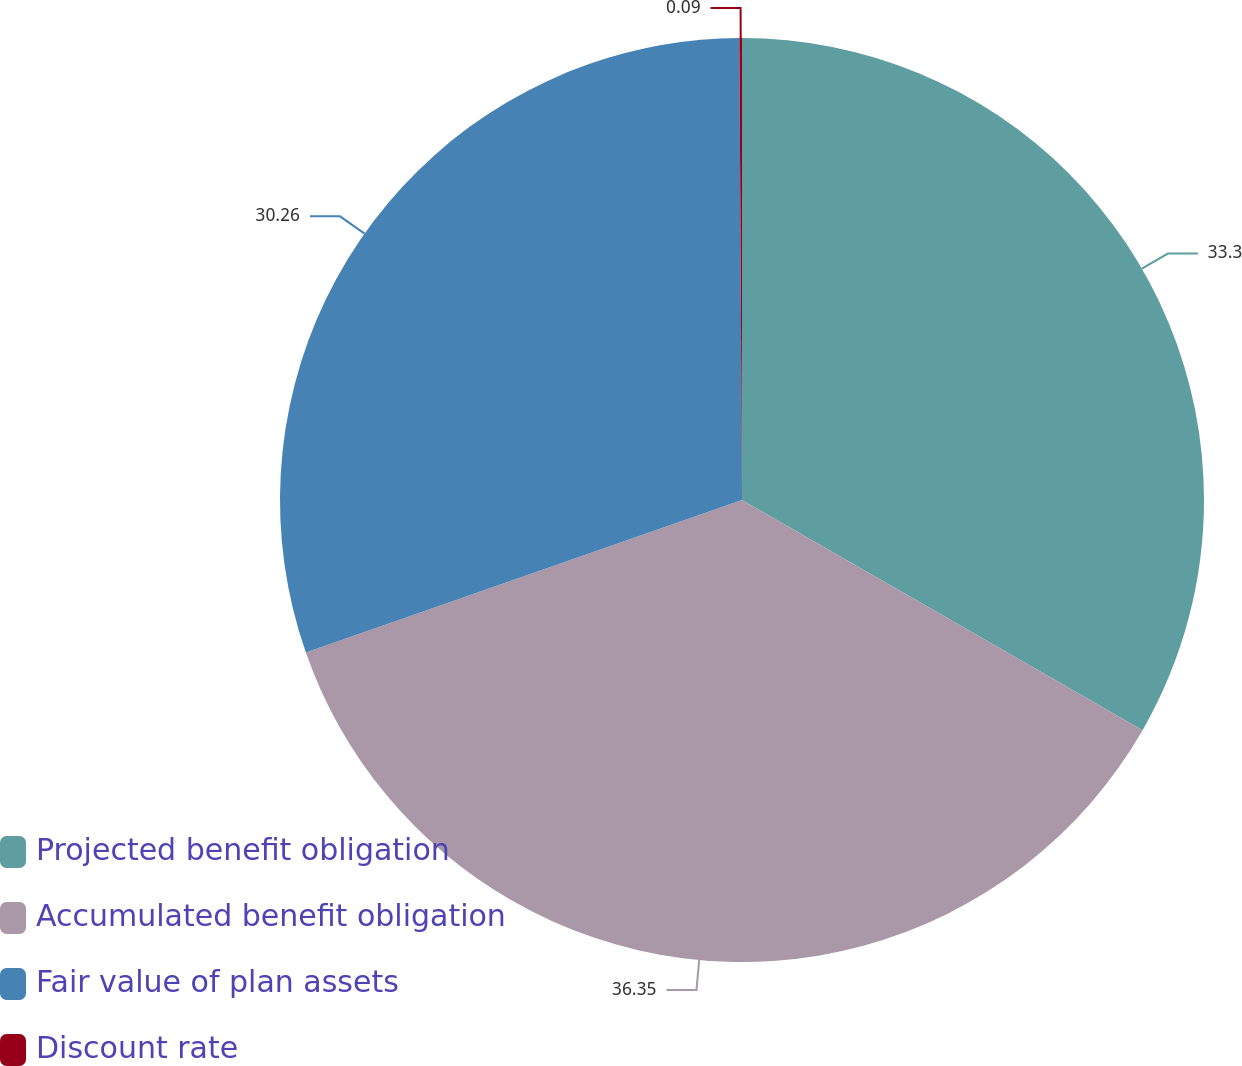<chart> <loc_0><loc_0><loc_500><loc_500><pie_chart><fcel>Projected benefit obligation<fcel>Accumulated benefit obligation<fcel>Fair value of plan assets<fcel>Discount rate<nl><fcel>33.3%<fcel>36.35%<fcel>30.26%<fcel>0.09%<nl></chart> 